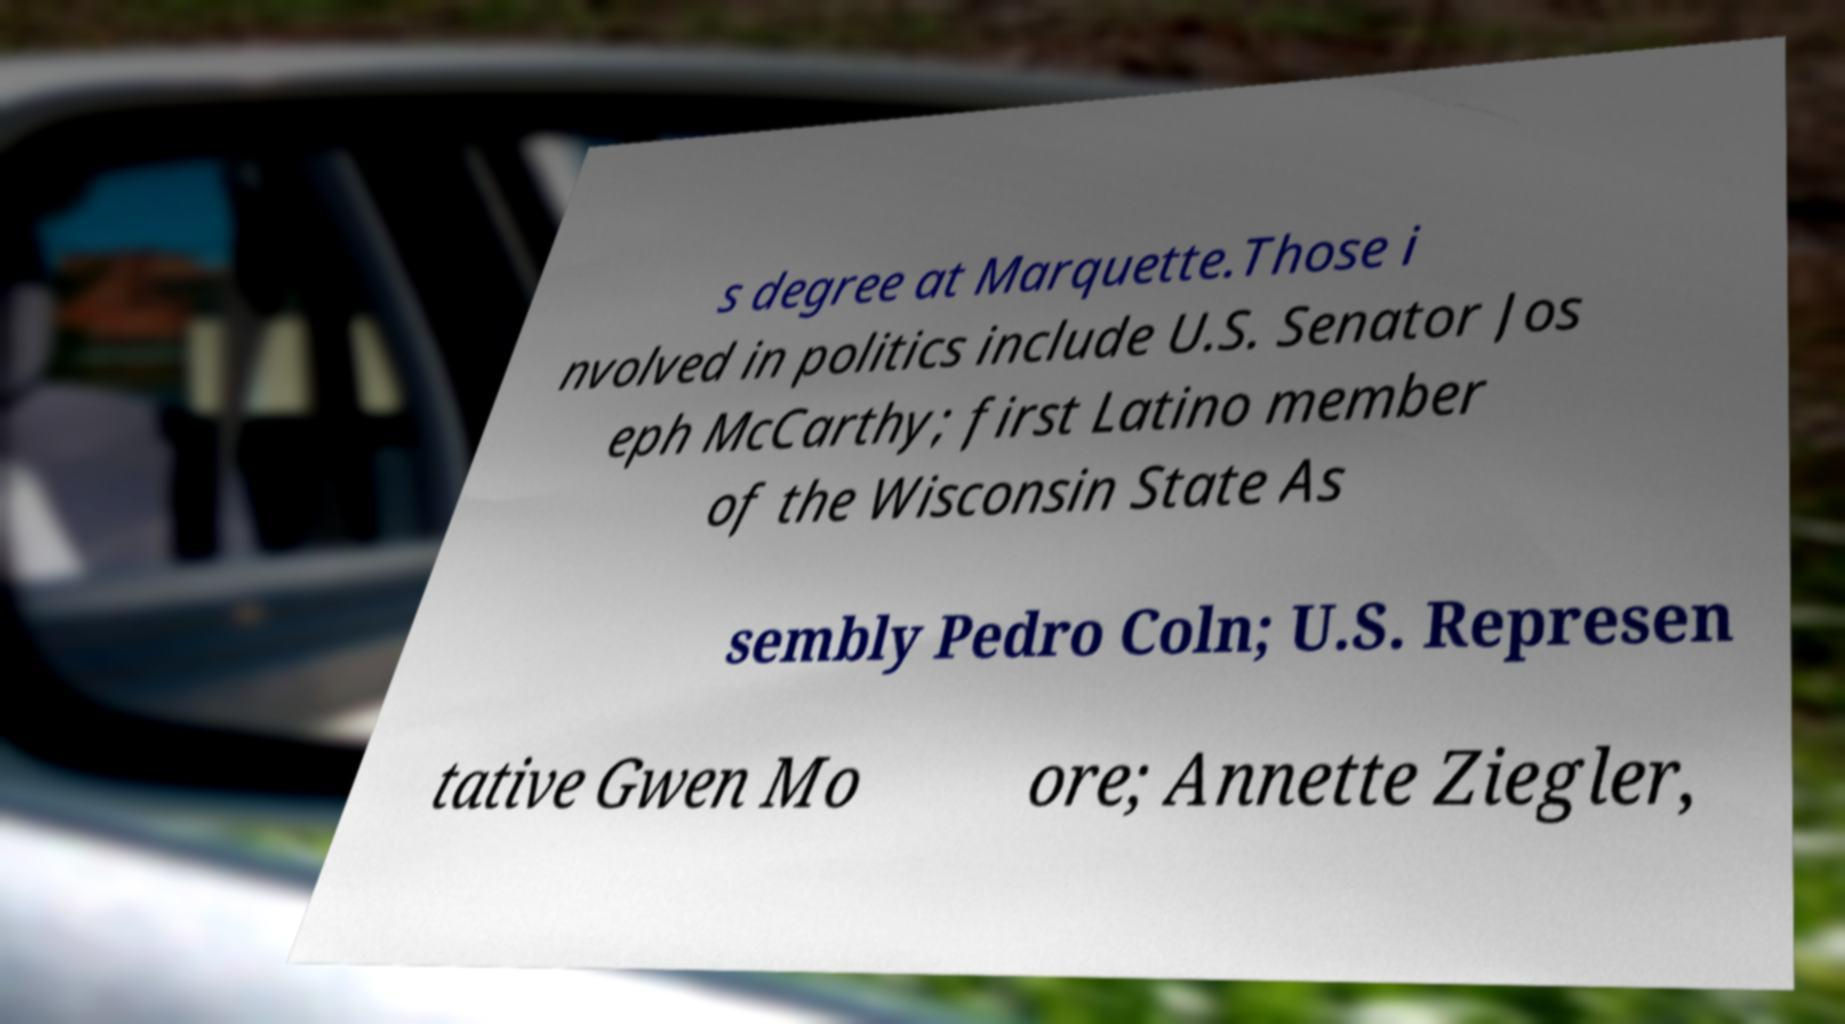What messages or text are displayed in this image? I need them in a readable, typed format. s degree at Marquette.Those i nvolved in politics include U.S. Senator Jos eph McCarthy; first Latino member of the Wisconsin State As sembly Pedro Coln; U.S. Represen tative Gwen Mo ore; Annette Ziegler, 